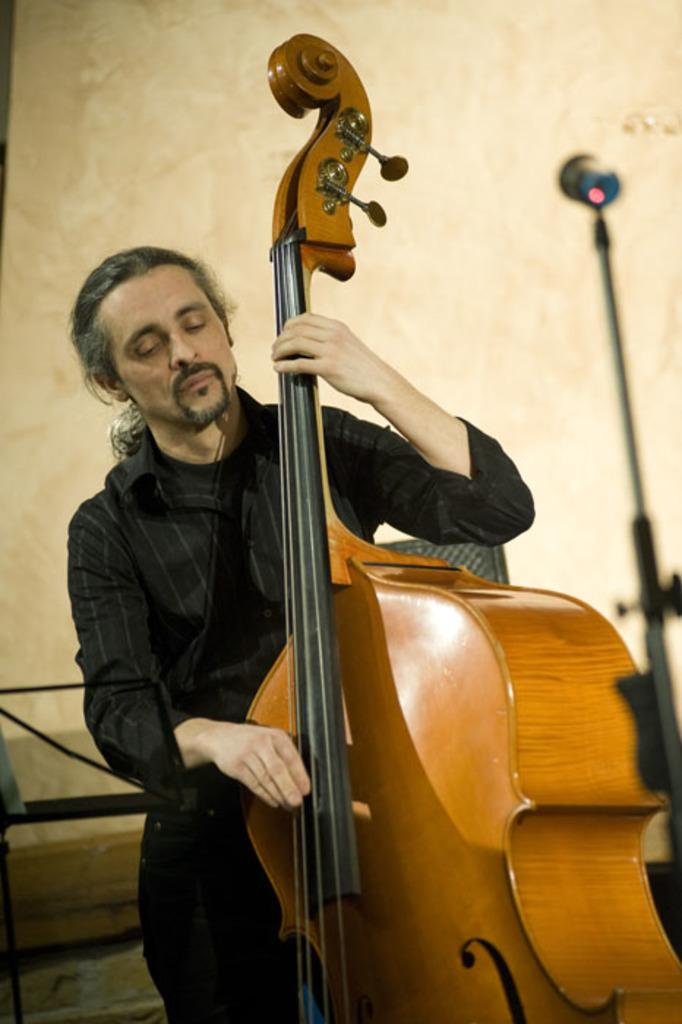What is happening in the image? There is a person in the image who is playing the violin. Can you describe the person's activity in more detail? The person is holding a violin and appears to be playing it, likely producing musical notes. What type of plot is being discussed in the meeting depicted in the image? There is no meeting or plot present in the image; it only features a person playing the violin. 